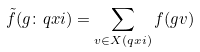Convert formula to latex. <formula><loc_0><loc_0><loc_500><loc_500>\tilde { f } ( g \colon \L q x i ) = \sum _ { v \in X ( \L q x i ) } f ( g v )</formula> 